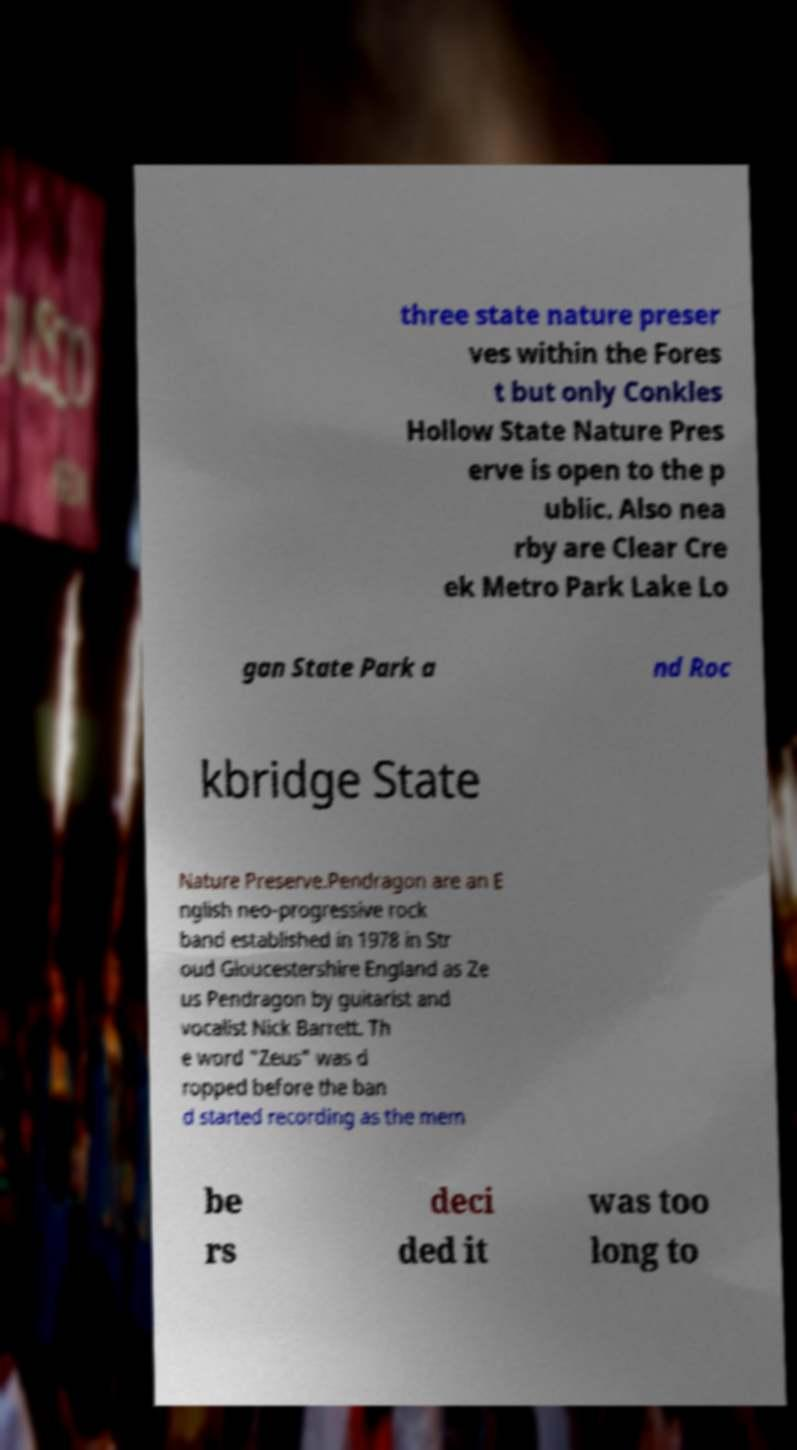Can you read and provide the text displayed in the image?This photo seems to have some interesting text. Can you extract and type it out for me? three state nature preser ves within the Fores t but only Conkles Hollow State Nature Pres erve is open to the p ublic. Also nea rby are Clear Cre ek Metro Park Lake Lo gan State Park a nd Roc kbridge State Nature Preserve.Pendragon are an E nglish neo-progressive rock band established in 1978 in Str oud Gloucestershire England as Ze us Pendragon by guitarist and vocalist Nick Barrett. Th e word "Zeus" was d ropped before the ban d started recording as the mem be rs deci ded it was too long to 